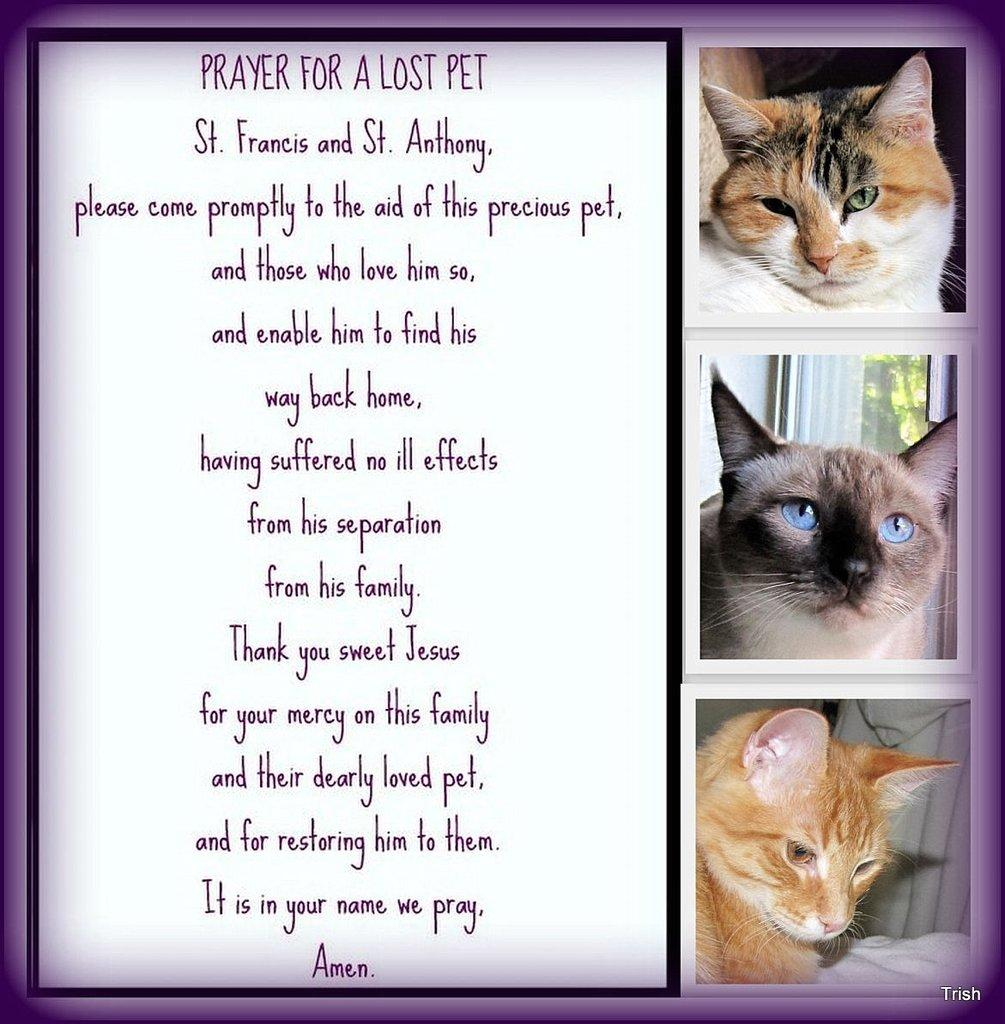What is present on the poster in the image? There is a poster in the image. What can be found on the poster besides images? The poster contains text. What type of animals are depicted on the poster? The poster has images of cats. How many tomatoes are on the poster? There are no tomatoes present on the poster; it features images of cats and text. 